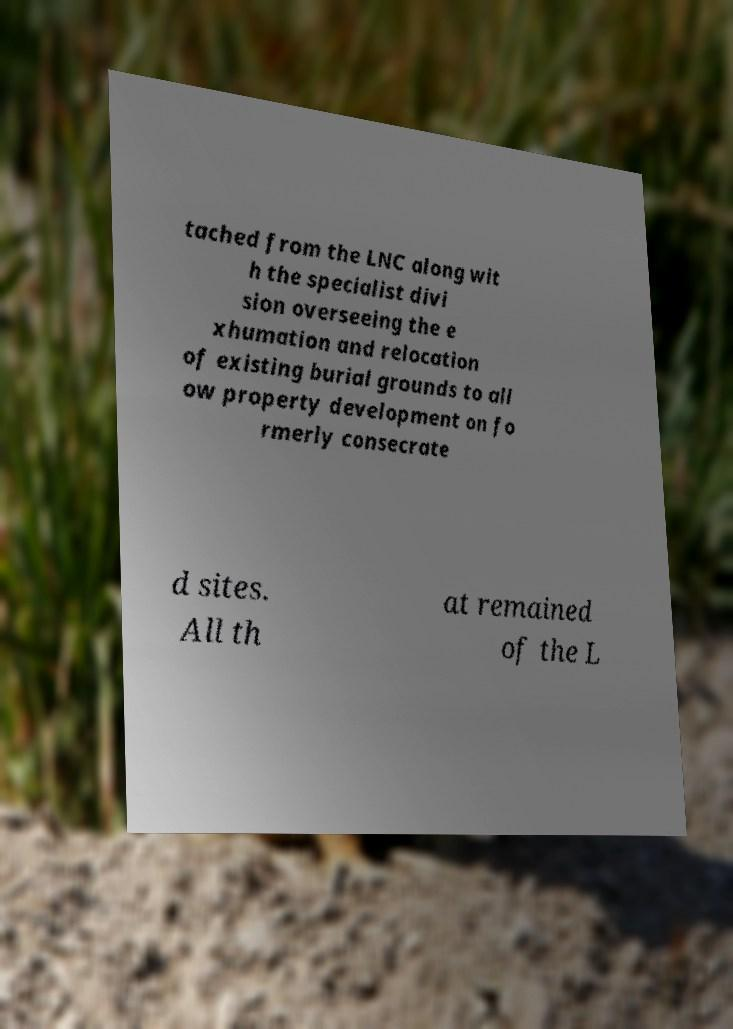Please identify and transcribe the text found in this image. tached from the LNC along wit h the specialist divi sion overseeing the e xhumation and relocation of existing burial grounds to all ow property development on fo rmerly consecrate d sites. All th at remained of the L 